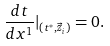<formula> <loc_0><loc_0><loc_500><loc_500>\frac { d t } { d x ^ { 1 } } | _ { ( t ^ { * } , \vec { z } _ { i } ) } = 0 .</formula> 